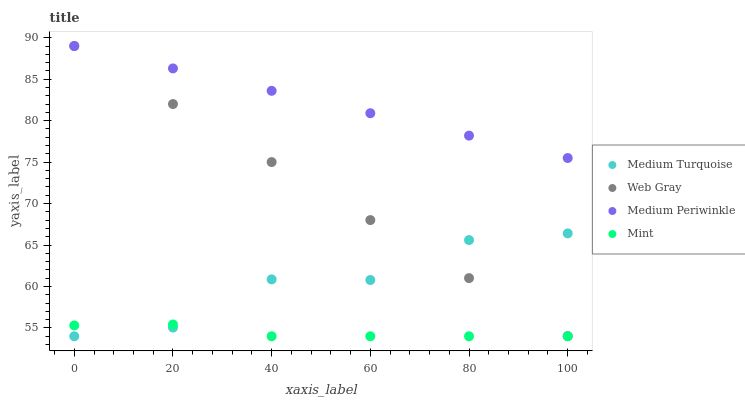Does Mint have the minimum area under the curve?
Answer yes or no. Yes. Does Medium Periwinkle have the maximum area under the curve?
Answer yes or no. Yes. Does Web Gray have the minimum area under the curve?
Answer yes or no. No. Does Web Gray have the maximum area under the curve?
Answer yes or no. No. Is Medium Periwinkle the smoothest?
Answer yes or no. Yes. Is Medium Turquoise the roughest?
Answer yes or no. Yes. Is Web Gray the smoothest?
Answer yes or no. No. Is Web Gray the roughest?
Answer yes or no. No. Does Mint have the lowest value?
Answer yes or no. Yes. Does Web Gray have the lowest value?
Answer yes or no. No. Does Medium Periwinkle have the highest value?
Answer yes or no. Yes. Does Medium Turquoise have the highest value?
Answer yes or no. No. Is Mint less than Web Gray?
Answer yes or no. Yes. Is Medium Periwinkle greater than Mint?
Answer yes or no. Yes. Does Medium Periwinkle intersect Web Gray?
Answer yes or no. Yes. Is Medium Periwinkle less than Web Gray?
Answer yes or no. No. Is Medium Periwinkle greater than Web Gray?
Answer yes or no. No. Does Mint intersect Web Gray?
Answer yes or no. No. 